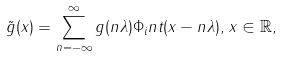<formula> <loc_0><loc_0><loc_500><loc_500>\tilde { g } ( x ) = \sum _ { n = - \infty } ^ { \infty } g ( n \lambda ) \Phi _ { i } n t ( x - n \lambda ) , \, x \in \mathbb { R } ,</formula> 